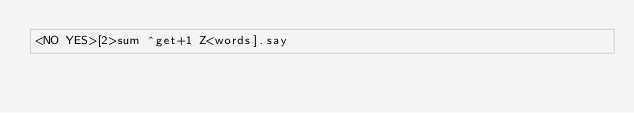Convert code to text. <code><loc_0><loc_0><loc_500><loc_500><_Perl_><NO YES>[2>sum ^get+1 Z<words].say</code> 